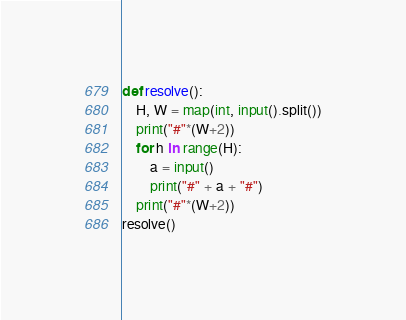Convert code to text. <code><loc_0><loc_0><loc_500><loc_500><_Python_>def resolve():
    H, W = map(int, input().split())
    print("#"*(W+2))
    for h in range(H):
        a = input()
        print("#" + a + "#")
    print("#"*(W+2))
resolve()</code> 